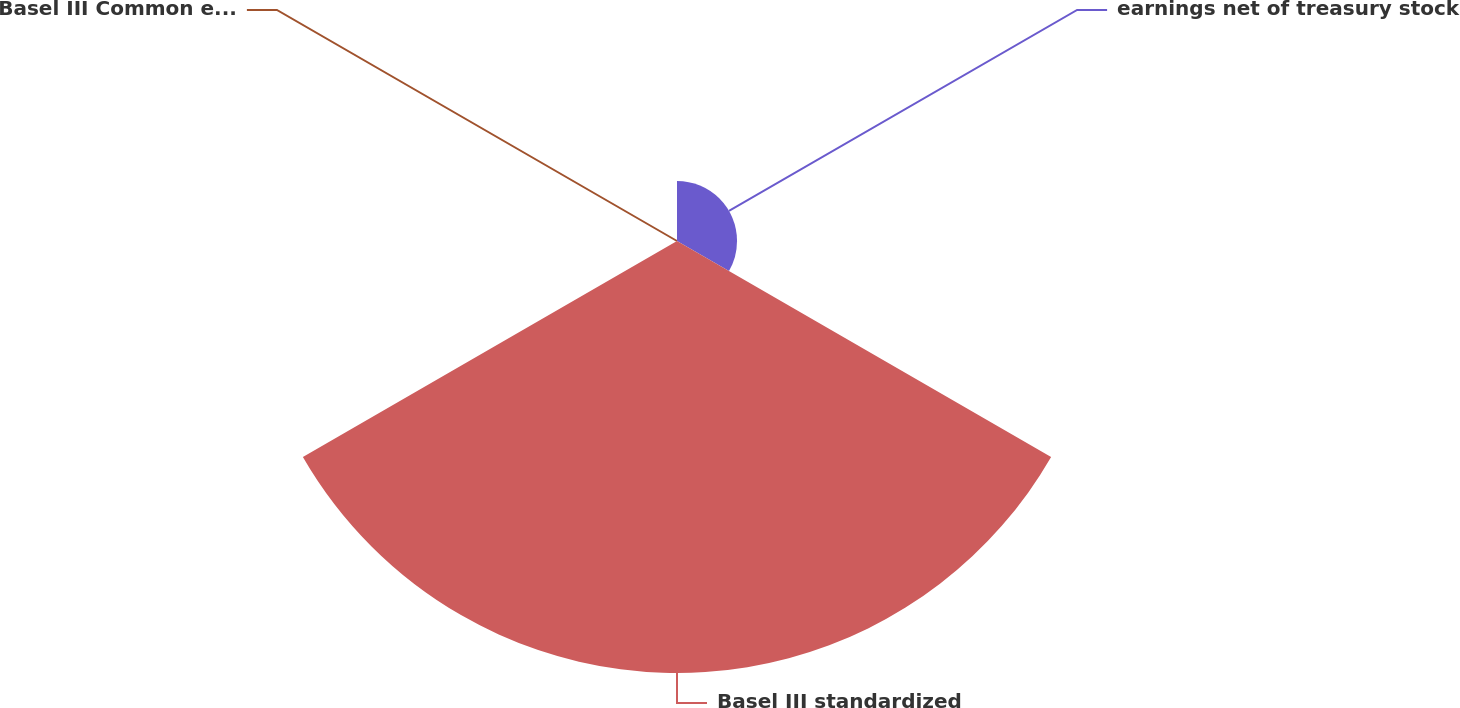Convert chart. <chart><loc_0><loc_0><loc_500><loc_500><pie_chart><fcel>earnings net of treasury stock<fcel>Basel III standardized<fcel>Basel III Common equity Tier 1<nl><fcel>12.2%<fcel>87.79%<fcel>0.0%<nl></chart> 